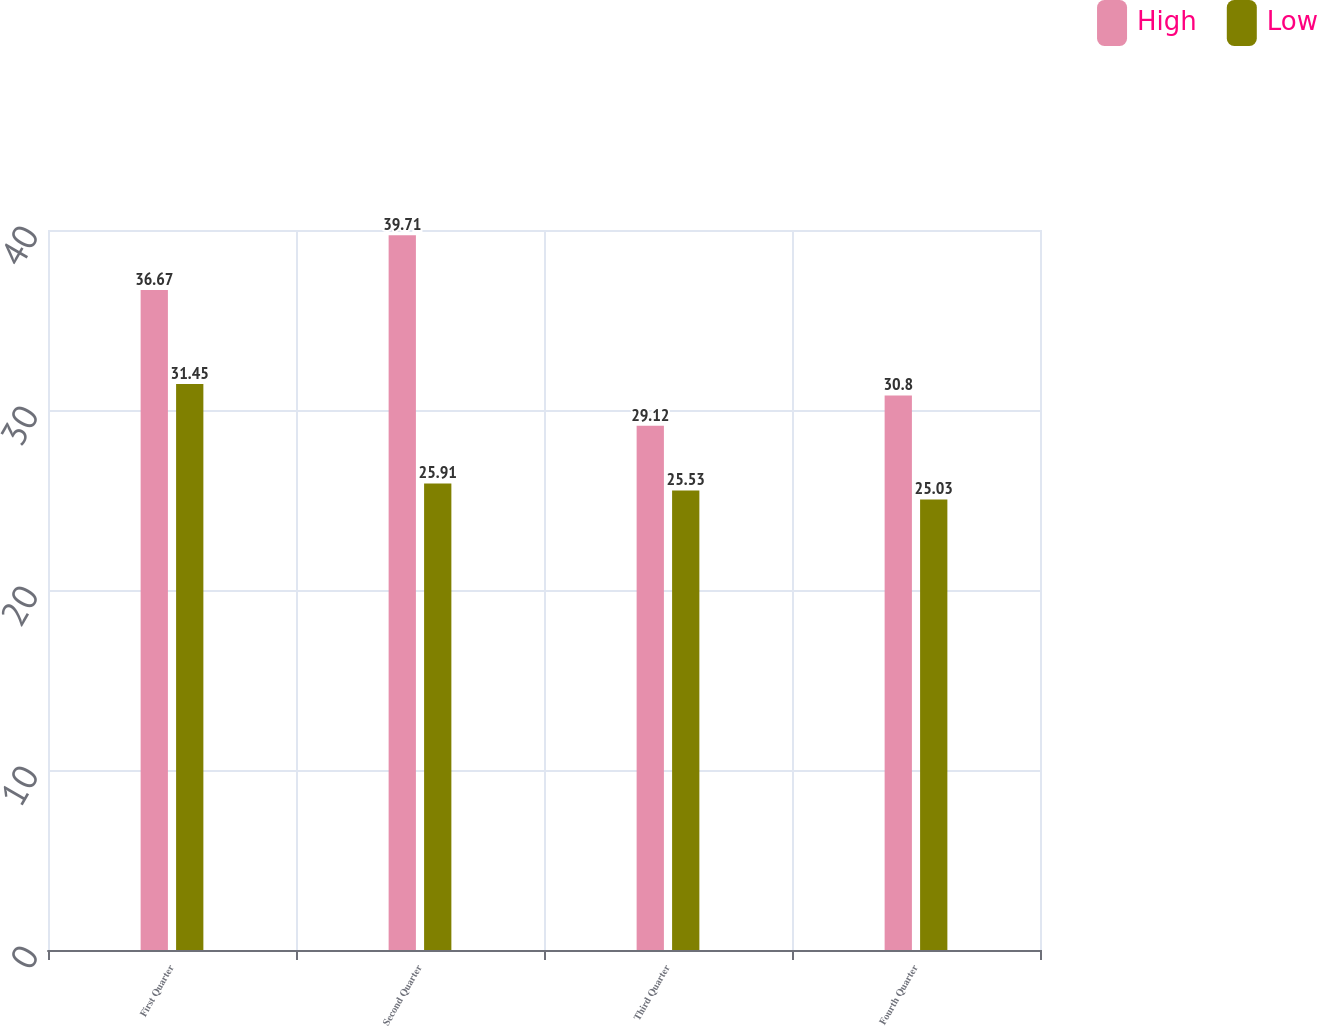Convert chart to OTSL. <chart><loc_0><loc_0><loc_500><loc_500><stacked_bar_chart><ecel><fcel>First Quarter<fcel>Second Quarter<fcel>Third Quarter<fcel>Fourth Quarter<nl><fcel>High<fcel>36.67<fcel>39.71<fcel>29.12<fcel>30.8<nl><fcel>Low<fcel>31.45<fcel>25.91<fcel>25.53<fcel>25.03<nl></chart> 